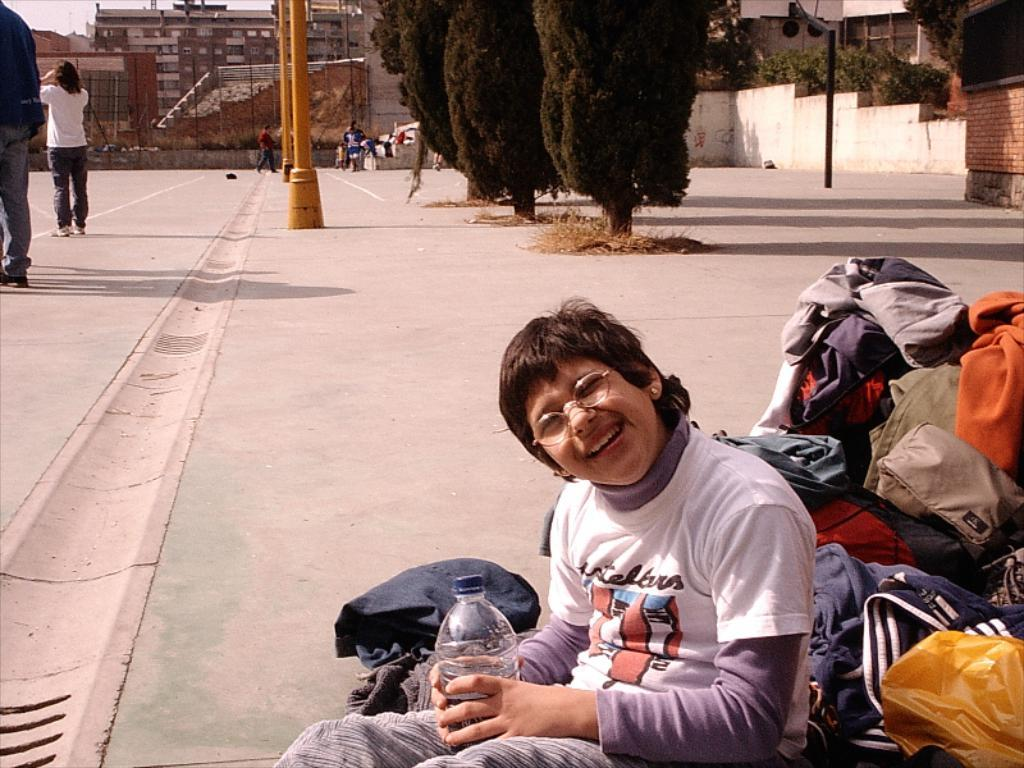What is the child in the image doing? The child is sitting in the image. What is the child holding? The child is holding a bottle. What can be seen in the background of the image? There are trees, people, and buildings visible in the background. What type of grain is being harvested by the horses in the image? There are no horses or grain present in the image. What kind of jewel is the child wearing in the image? There is no mention of a jewel being worn by the child in the image. 